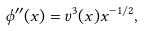Convert formula to latex. <formula><loc_0><loc_0><loc_500><loc_500>\phi ^ { \prime \prime } ( x ) = v ^ { 3 } ( x ) x ^ { - 1 / 2 } ,</formula> 